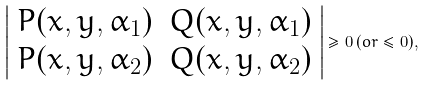Convert formula to latex. <formula><loc_0><loc_0><loc_500><loc_500>\left | \begin{array} { c c } P ( x , y , \alpha _ { 1 } ) & Q ( x , y , \alpha _ { 1 } ) \\ P ( x , y , \alpha _ { 2 } ) & Q ( x , y , \alpha _ { 2 } ) \end{array} \right | \geq 0 \, ( o r \leq 0 ) ,</formula> 